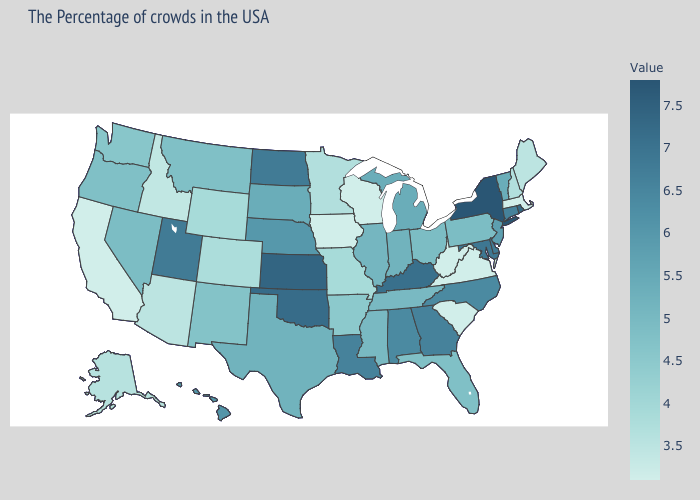Does New York have the highest value in the USA?
Quick response, please. Yes. Which states hav the highest value in the Northeast?
Answer briefly. New York. Is the legend a continuous bar?
Write a very short answer. Yes. Which states have the highest value in the USA?
Give a very brief answer. New York. 